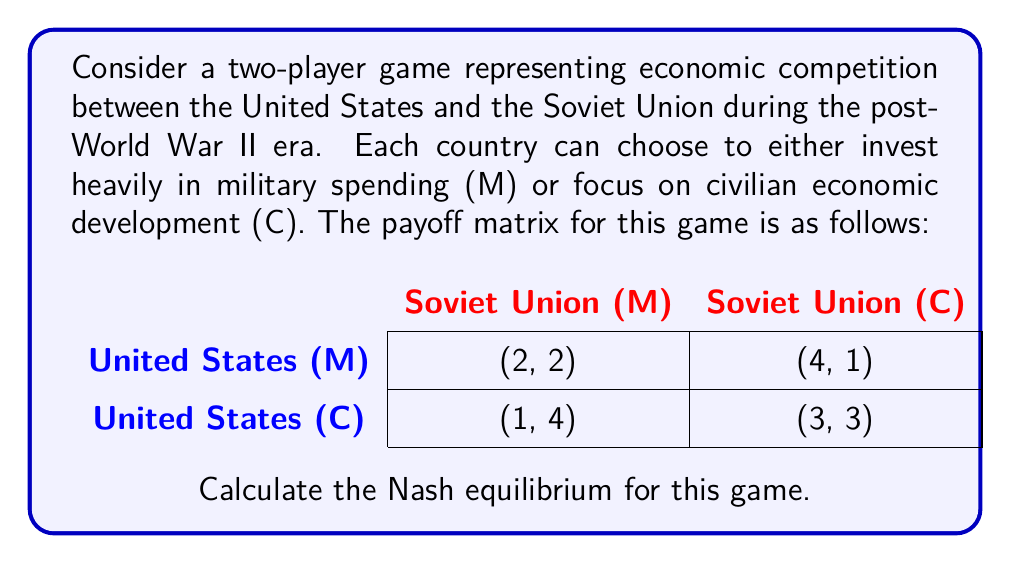Can you answer this question? To find the Nash equilibrium, we need to determine the best response for each player given the other player's strategy. Let's analyze this step-by-step:

1. First, consider the United States' perspective:
   - If the Soviet Union chooses M, the US gets 2 from M and 1 from C. So, M is better.
   - If the Soviet Union chooses C, the US gets 4 from M and 3 from C. So, M is better.

2. Now, consider the Soviet Union's perspective:
   - If the US chooses M, the Soviet Union gets 2 from M and 1 from C. So, M is better.
   - If the US chooses C, the Soviet Union gets 4 from M and 3 from C. So, M is better.

3. We can see that regardless of what the other player does, both countries always prefer to choose M (military spending).

4. The definition of a Nash equilibrium is a set of strategies where no player can unilaterally improve their payoff by changing their strategy.

5. In this case, when both countries choose M, neither can improve their payoff by switching to C:
   - If the US unilaterally switches to C, its payoff decreases from 2 to 1.
   - If the Soviet Union unilaterally switches to C, its payoff decreases from 2 to 1.

Therefore, (M, M) is a Nash equilibrium. Moreover, it is the only Nash equilibrium in this game, as both players have a dominant strategy (M).

This result reflects the historical reality of the arms race during the Cold War, where both superpowers invested heavily in military spending at the expense of civilian economic development.
Answer: The Nash equilibrium for this game is (M, M), where both the United States and the Soviet Union choose to invest heavily in military spending. 